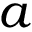<formula> <loc_0><loc_0><loc_500><loc_500>a</formula> 